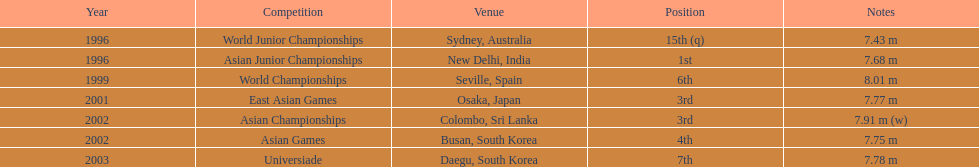What is the total count of competitions participated in? 7. 